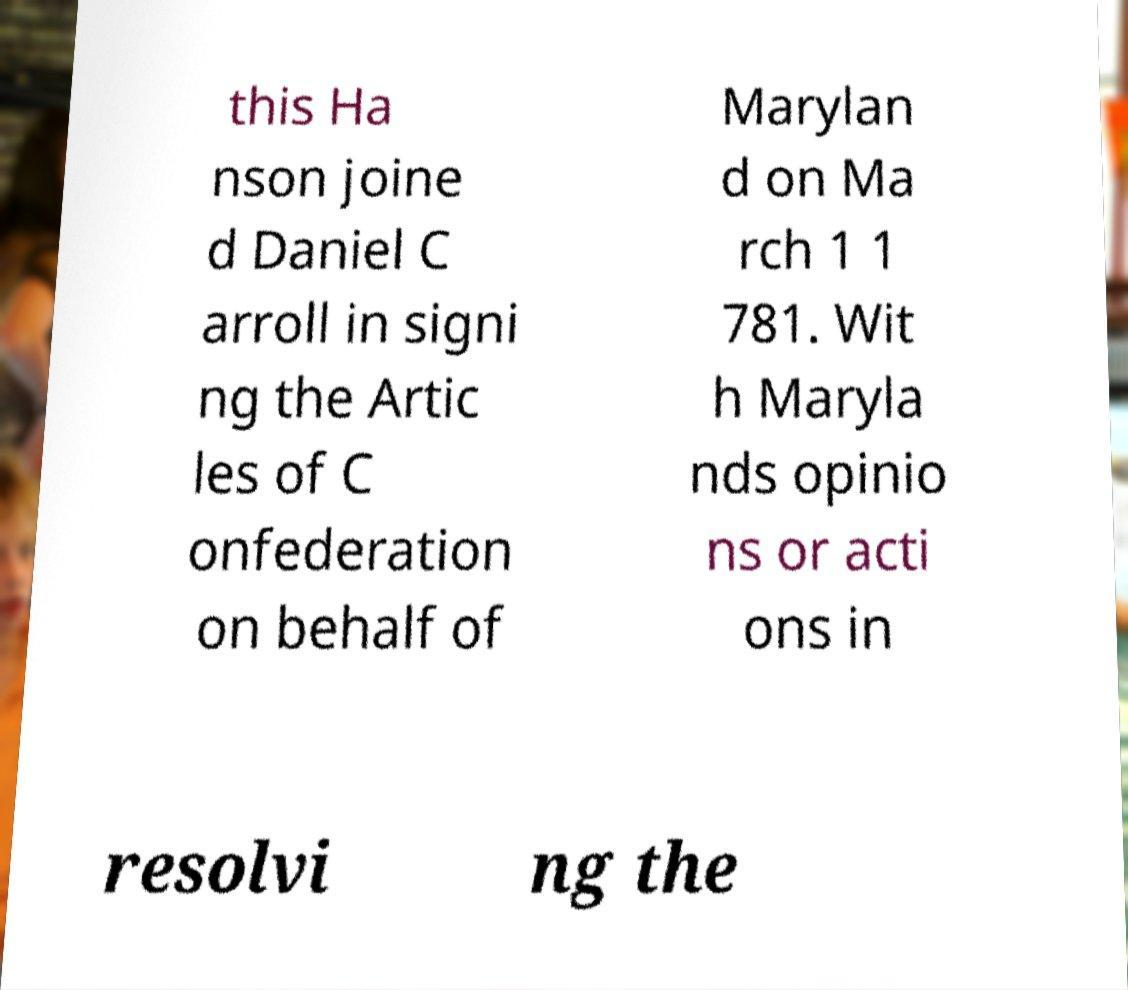There's text embedded in this image that I need extracted. Can you transcribe it verbatim? this Ha nson joine d Daniel C arroll in signi ng the Artic les of C onfederation on behalf of Marylan d on Ma rch 1 1 781. Wit h Maryla nds opinio ns or acti ons in resolvi ng the 